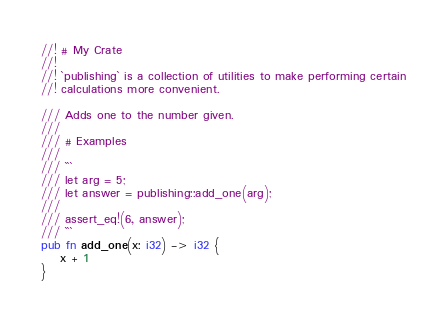Convert code to text. <code><loc_0><loc_0><loc_500><loc_500><_Rust_>//! # My Crate
//!
//! `publishing` is a collection of utilities to make performing certain
//! calculations more convenient.

/// Adds one to the number given.
///
/// # Examples
///
/// ```
/// let arg = 5;
/// let answer = publishing::add_one(arg);
///
/// assert_eq!(6, answer);
/// ```
pub fn add_one(x: i32) -> i32 {
    x + 1
}
</code> 